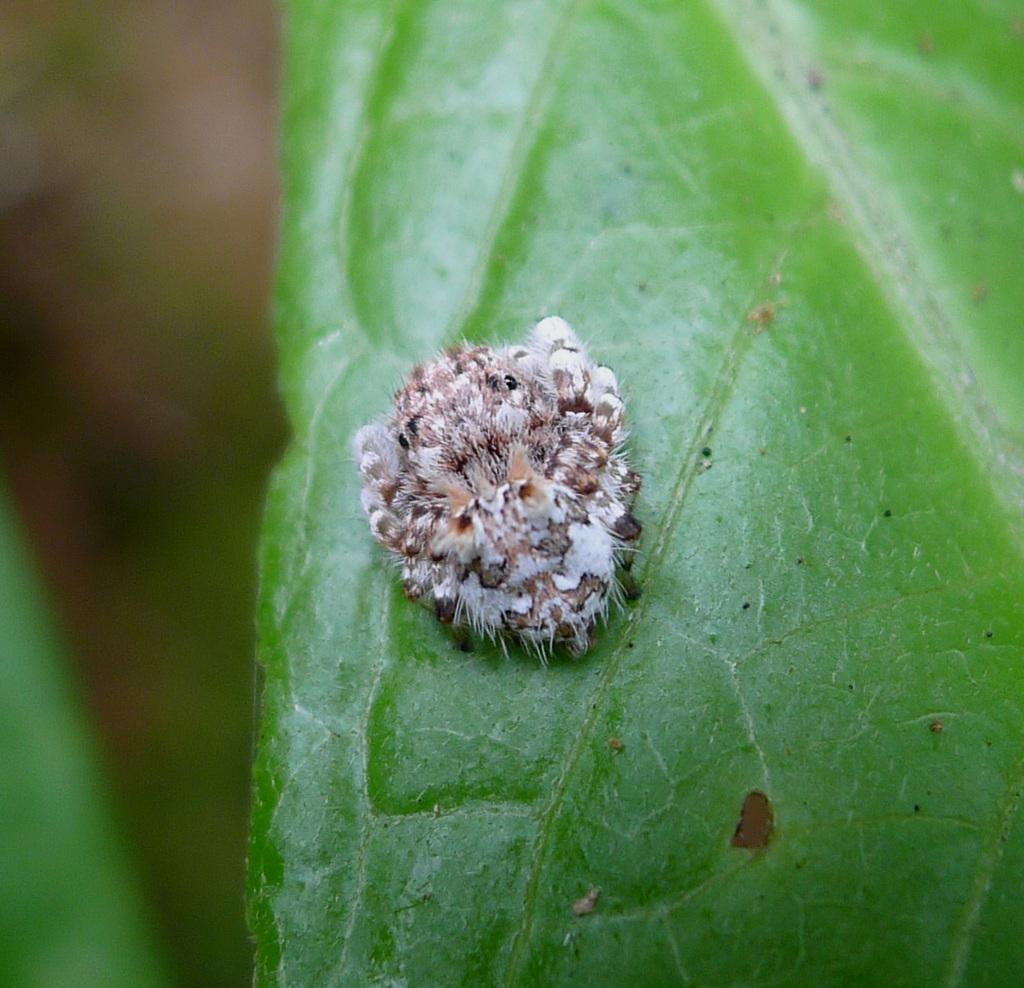How would you summarize this image in a sentence or two? This is a zoomed in picture. In the center there is an insect on the green color leaf. The background of the image is blurry. 